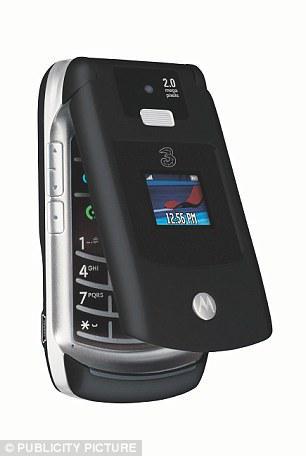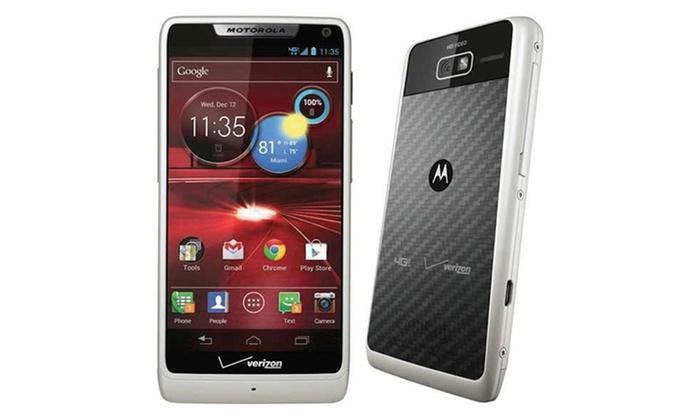The first image is the image on the left, the second image is the image on the right. For the images displayed, is the sentence "There is a single phone in the left image." factually correct? Answer yes or no. Yes. The first image is the image on the left, the second image is the image on the right. For the images shown, is this caption "There is a single cell phone in the image on the left and at least twice as many on the right." true? Answer yes or no. Yes. 